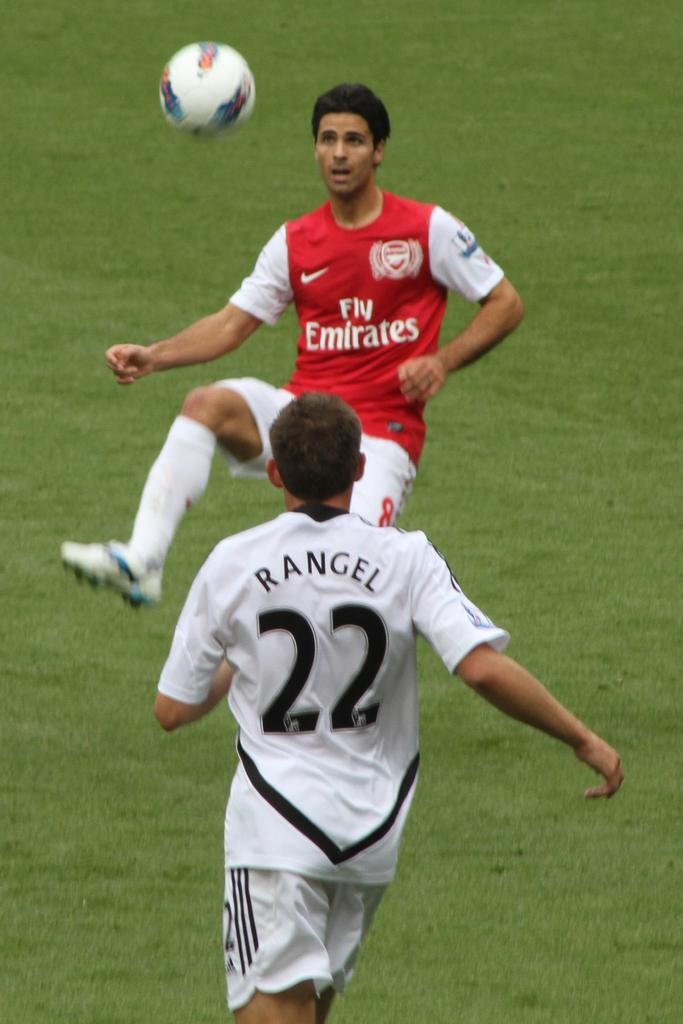<image>
Share a concise interpretation of the image provided. A player with a jersey that reads Rangel heads for the ball. 